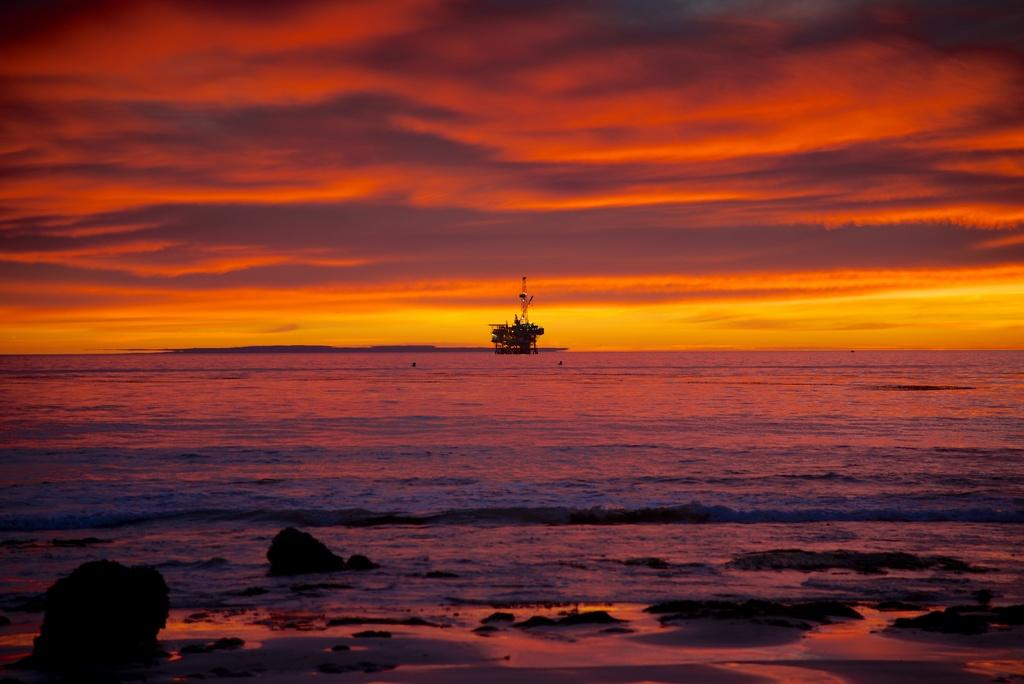What is the main subject in the center of the image? There is a boat in the center of the image. What can be seen in the background of the image? There is a wall in the background of the image. What is visible at the top of the image? The sky is visible at the top of the image. What type of terrain is at the bottom of the image? There are rocks at the bottom of the image. How much sugar is present in the boat in the image? There is no sugar present in the boat or the image; it is a boat on a body of water with a wall, sky, and rocks visible. 